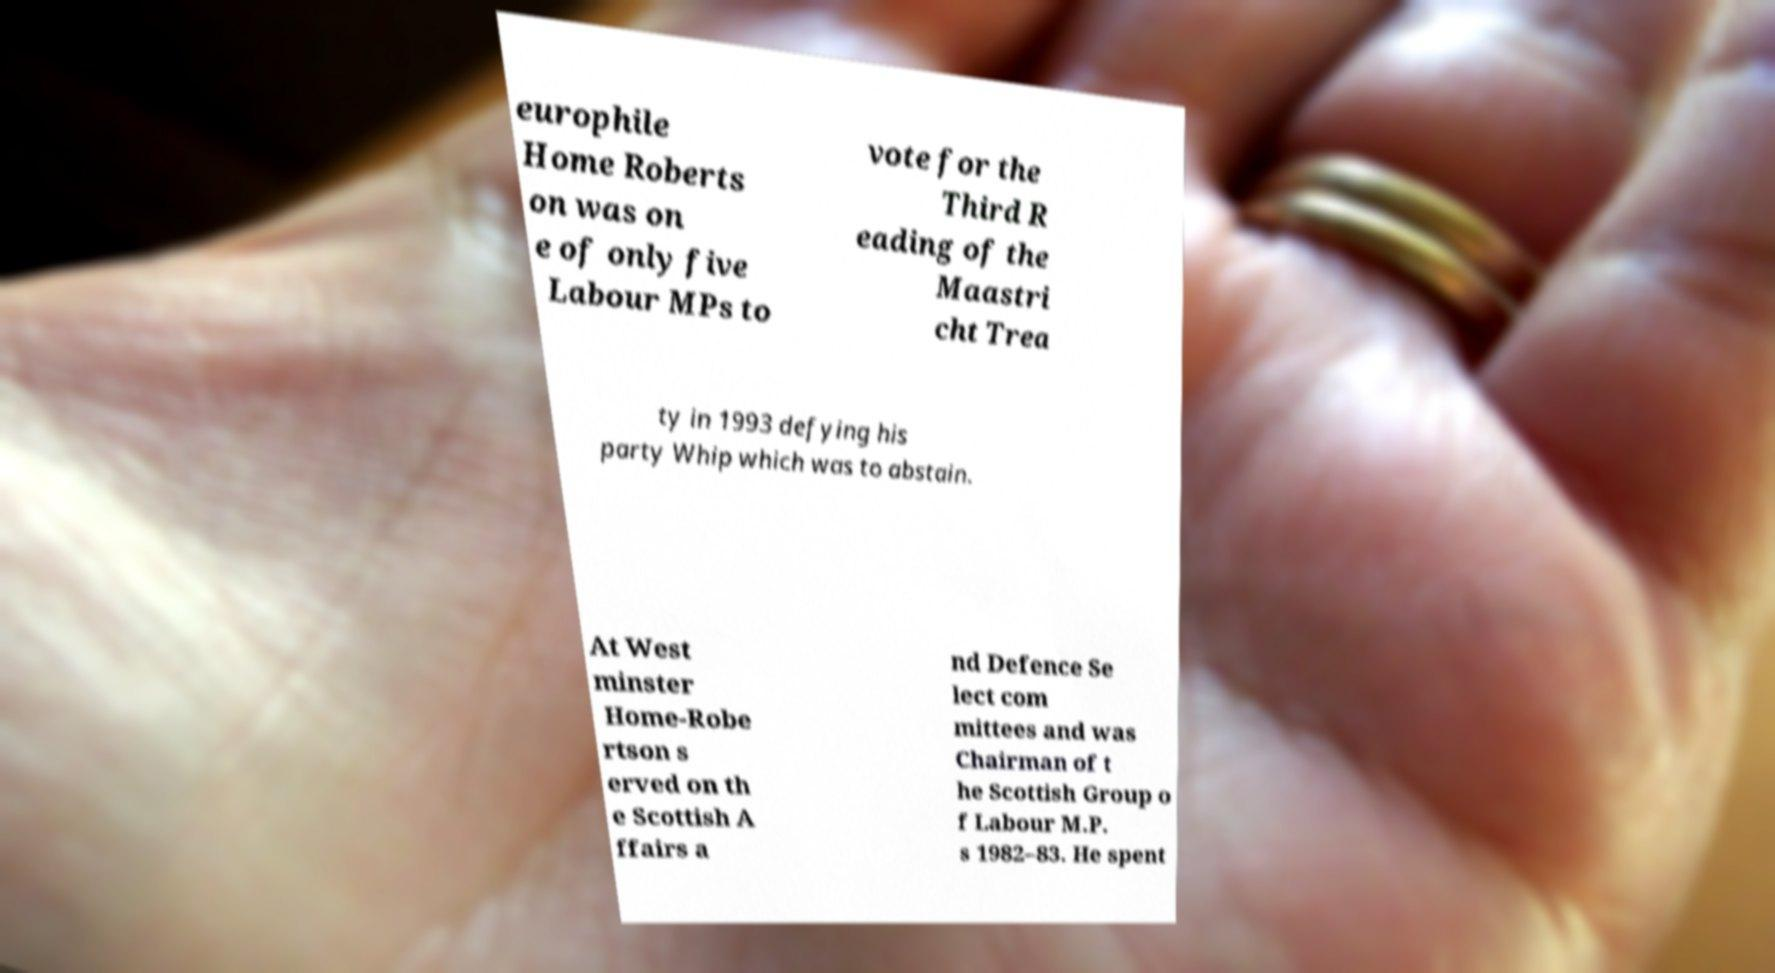For documentation purposes, I need the text within this image transcribed. Could you provide that? europhile Home Roberts on was on e of only five Labour MPs to vote for the Third R eading of the Maastri cht Trea ty in 1993 defying his party Whip which was to abstain. At West minster Home-Robe rtson s erved on th e Scottish A ffairs a nd Defence Se lect com mittees and was Chairman of t he Scottish Group o f Labour M.P. s 1982–83. He spent 